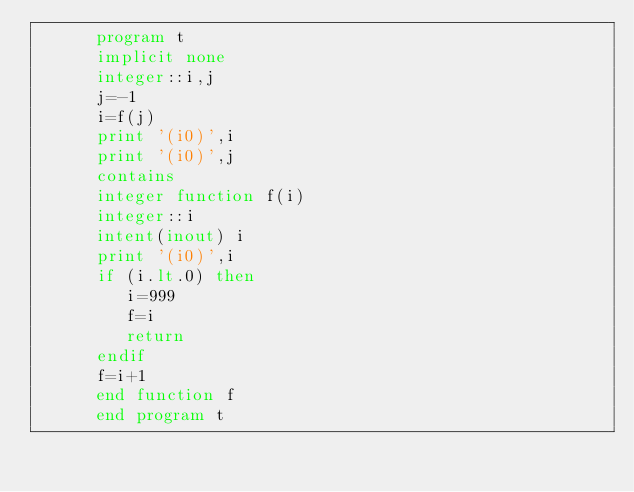Convert code to text. <code><loc_0><loc_0><loc_500><loc_500><_FORTRAN_>      program t
      implicit none
      integer::i,j
      j=-1
      i=f(j)
      print '(i0)',i
      print '(i0)',j
      contains
      integer function f(i)
      integer::i
      intent(inout) i
      print '(i0)',i
      if (i.lt.0) then
         i=999
         f=i
         return
      endif
      f=i+1
      end function f
      end program t
</code> 